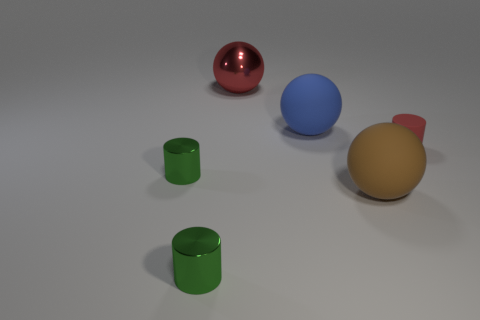Subtract all big rubber spheres. How many spheres are left? 1 Add 1 rubber cylinders. How many objects exist? 7 Subtract all green cylinders. How many cylinders are left? 1 Subtract 1 spheres. How many spheres are left? 2 Subtract 0 purple spheres. How many objects are left? 6 Subtract all green cylinders. Subtract all green cubes. How many cylinders are left? 1 Subtract all purple cylinders. How many green balls are left? 0 Subtract all small green cylinders. Subtract all cylinders. How many objects are left? 1 Add 5 tiny things. How many tiny things are left? 8 Add 4 red rubber cubes. How many red rubber cubes exist? 4 